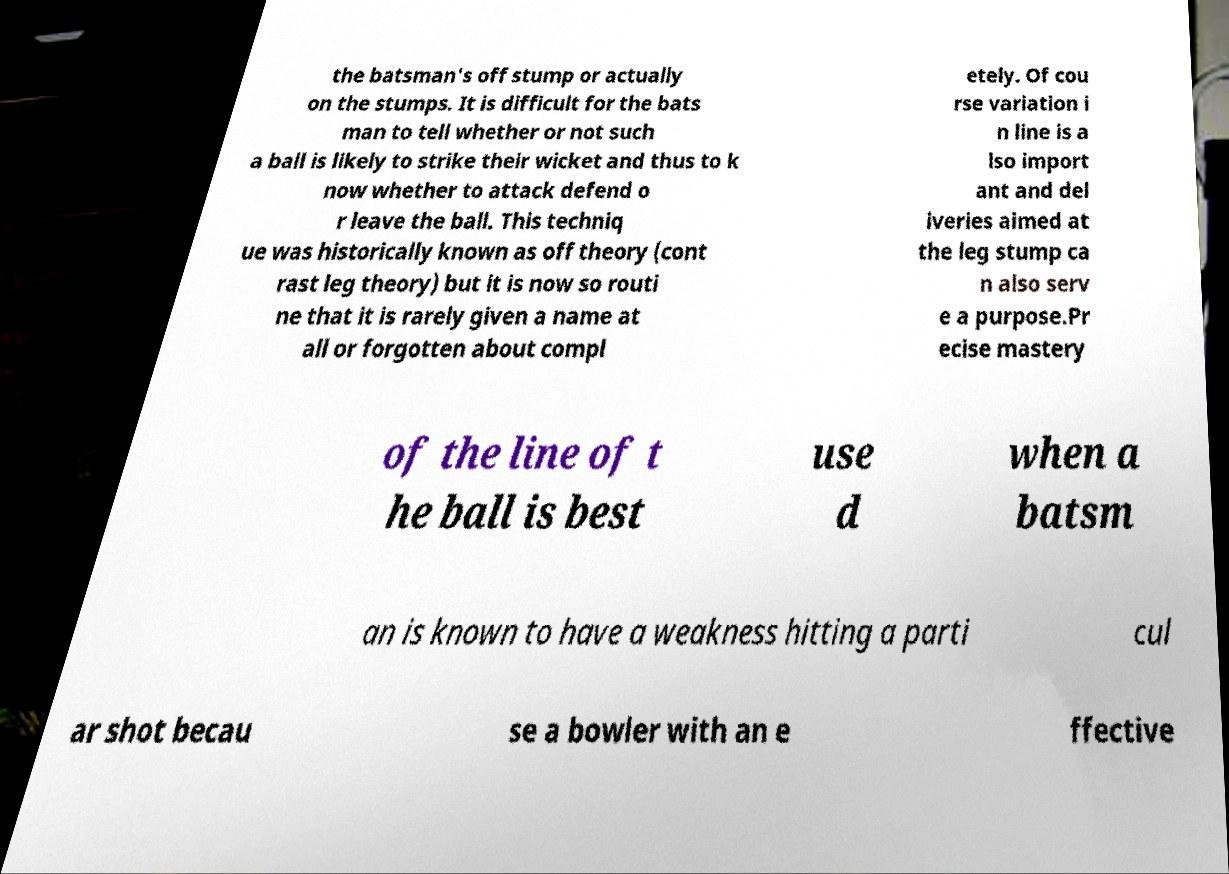Can you read and provide the text displayed in the image?This photo seems to have some interesting text. Can you extract and type it out for me? the batsman's off stump or actually on the stumps. It is difficult for the bats man to tell whether or not such a ball is likely to strike their wicket and thus to k now whether to attack defend o r leave the ball. This techniq ue was historically known as off theory (cont rast leg theory) but it is now so routi ne that it is rarely given a name at all or forgotten about compl etely. Of cou rse variation i n line is a lso import ant and del iveries aimed at the leg stump ca n also serv e a purpose.Pr ecise mastery of the line of t he ball is best use d when a batsm an is known to have a weakness hitting a parti cul ar shot becau se a bowler with an e ffective 